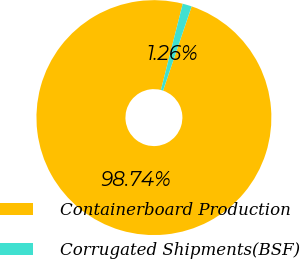Convert chart. <chart><loc_0><loc_0><loc_500><loc_500><pie_chart><fcel>Containerboard Production<fcel>Corrugated Shipments(BSF)<nl><fcel>98.74%<fcel>1.26%<nl></chart> 